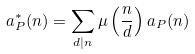Convert formula to latex. <formula><loc_0><loc_0><loc_500><loc_500>a _ { P } ^ { \ast } ( n ) = \sum _ { d | n } \mu \left ( \frac { n } { d } \right ) a _ { P } ( n )</formula> 